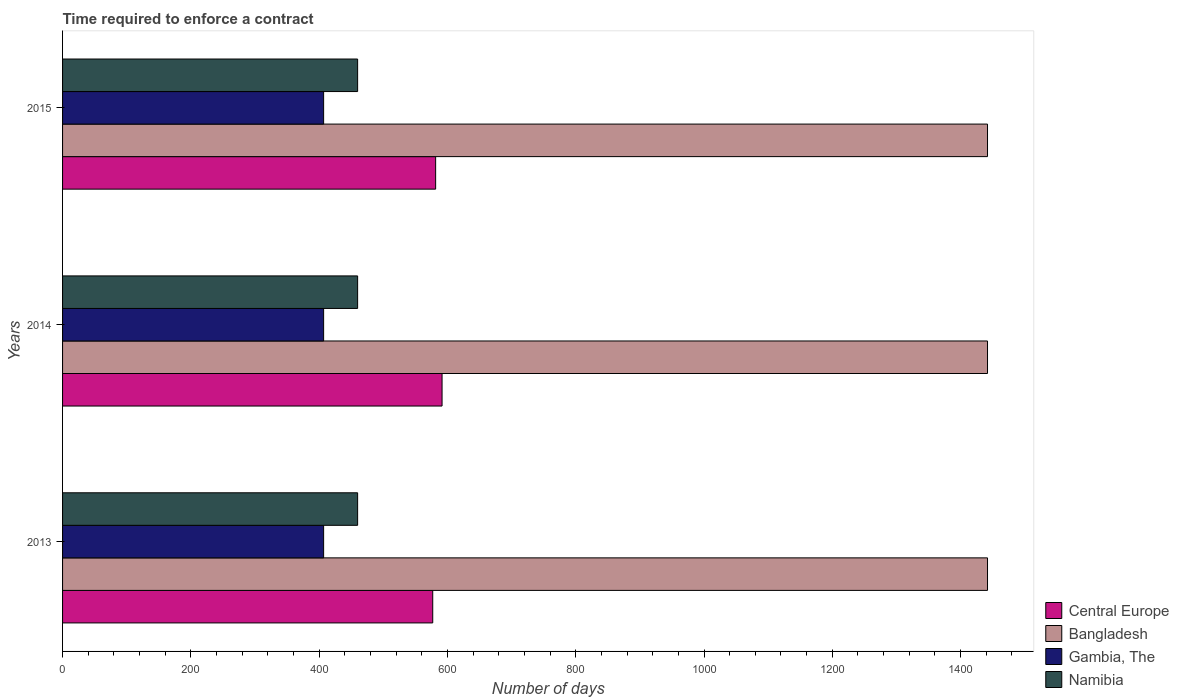How many groups of bars are there?
Keep it short and to the point. 3. Are the number of bars per tick equal to the number of legend labels?
Give a very brief answer. Yes. Are the number of bars on each tick of the Y-axis equal?
Ensure brevity in your answer.  Yes. What is the label of the 2nd group of bars from the top?
Offer a terse response. 2014. In how many cases, is the number of bars for a given year not equal to the number of legend labels?
Your answer should be very brief. 0. What is the number of days required to enforce a contract in Central Europe in 2014?
Keep it short and to the point. 591.64. Across all years, what is the maximum number of days required to enforce a contract in Namibia?
Your response must be concise. 460. Across all years, what is the minimum number of days required to enforce a contract in Bangladesh?
Ensure brevity in your answer.  1442. What is the total number of days required to enforce a contract in Namibia in the graph?
Your answer should be compact. 1380. What is the difference between the number of days required to enforce a contract in Gambia, The in 2014 and the number of days required to enforce a contract in Central Europe in 2013?
Provide a short and direct response. -170.09. What is the average number of days required to enforce a contract in Bangladesh per year?
Your response must be concise. 1442. In the year 2015, what is the difference between the number of days required to enforce a contract in Central Europe and number of days required to enforce a contract in Namibia?
Make the answer very short. 121.64. In how many years, is the number of days required to enforce a contract in Namibia greater than 1080 days?
Keep it short and to the point. 0. What is the ratio of the number of days required to enforce a contract in Gambia, The in 2013 to that in 2015?
Your answer should be compact. 1. Is the number of days required to enforce a contract in Bangladesh in 2013 less than that in 2014?
Offer a very short reply. No. What is the difference between the highest and the lowest number of days required to enforce a contract in Bangladesh?
Provide a succinct answer. 0. Is the sum of the number of days required to enforce a contract in Gambia, The in 2014 and 2015 greater than the maximum number of days required to enforce a contract in Bangladesh across all years?
Provide a short and direct response. No. Is it the case that in every year, the sum of the number of days required to enforce a contract in Bangladesh and number of days required to enforce a contract in Namibia is greater than the sum of number of days required to enforce a contract in Gambia, The and number of days required to enforce a contract in Central Europe?
Make the answer very short. Yes. What does the 1st bar from the top in 2014 represents?
Make the answer very short. Namibia. What does the 1st bar from the bottom in 2013 represents?
Offer a terse response. Central Europe. Are all the bars in the graph horizontal?
Provide a short and direct response. Yes. How many years are there in the graph?
Keep it short and to the point. 3. Does the graph contain any zero values?
Ensure brevity in your answer.  No. What is the title of the graph?
Offer a very short reply. Time required to enforce a contract. Does "Australia" appear as one of the legend labels in the graph?
Give a very brief answer. No. What is the label or title of the X-axis?
Your answer should be compact. Number of days. What is the label or title of the Y-axis?
Provide a short and direct response. Years. What is the Number of days in Central Europe in 2013?
Offer a very short reply. 577.09. What is the Number of days of Bangladesh in 2013?
Ensure brevity in your answer.  1442. What is the Number of days in Gambia, The in 2013?
Offer a terse response. 407. What is the Number of days of Namibia in 2013?
Keep it short and to the point. 460. What is the Number of days in Central Europe in 2014?
Your answer should be compact. 591.64. What is the Number of days in Bangladesh in 2014?
Offer a very short reply. 1442. What is the Number of days in Gambia, The in 2014?
Make the answer very short. 407. What is the Number of days in Namibia in 2014?
Provide a short and direct response. 460. What is the Number of days of Central Europe in 2015?
Your answer should be very brief. 581.64. What is the Number of days in Bangladesh in 2015?
Ensure brevity in your answer.  1442. What is the Number of days in Gambia, The in 2015?
Make the answer very short. 407. What is the Number of days of Namibia in 2015?
Provide a succinct answer. 460. Across all years, what is the maximum Number of days in Central Europe?
Keep it short and to the point. 591.64. Across all years, what is the maximum Number of days of Bangladesh?
Your response must be concise. 1442. Across all years, what is the maximum Number of days in Gambia, The?
Offer a very short reply. 407. Across all years, what is the maximum Number of days in Namibia?
Your answer should be very brief. 460. Across all years, what is the minimum Number of days in Central Europe?
Provide a short and direct response. 577.09. Across all years, what is the minimum Number of days of Bangladesh?
Offer a very short reply. 1442. Across all years, what is the minimum Number of days of Gambia, The?
Make the answer very short. 407. Across all years, what is the minimum Number of days in Namibia?
Your answer should be compact. 460. What is the total Number of days in Central Europe in the graph?
Your answer should be very brief. 1750.36. What is the total Number of days of Bangladesh in the graph?
Your response must be concise. 4326. What is the total Number of days of Gambia, The in the graph?
Provide a succinct answer. 1221. What is the total Number of days in Namibia in the graph?
Your answer should be very brief. 1380. What is the difference between the Number of days of Central Europe in 2013 and that in 2014?
Offer a very short reply. -14.55. What is the difference between the Number of days of Gambia, The in 2013 and that in 2014?
Offer a terse response. 0. What is the difference between the Number of days of Namibia in 2013 and that in 2014?
Provide a short and direct response. 0. What is the difference between the Number of days of Central Europe in 2013 and that in 2015?
Offer a very short reply. -4.55. What is the difference between the Number of days of Bangladesh in 2013 and that in 2015?
Offer a terse response. 0. What is the difference between the Number of days of Gambia, The in 2013 and that in 2015?
Ensure brevity in your answer.  0. What is the difference between the Number of days of Central Europe in 2014 and that in 2015?
Your answer should be very brief. 10. What is the difference between the Number of days of Gambia, The in 2014 and that in 2015?
Provide a succinct answer. 0. What is the difference between the Number of days in Central Europe in 2013 and the Number of days in Bangladesh in 2014?
Provide a short and direct response. -864.91. What is the difference between the Number of days in Central Europe in 2013 and the Number of days in Gambia, The in 2014?
Provide a short and direct response. 170.09. What is the difference between the Number of days of Central Europe in 2013 and the Number of days of Namibia in 2014?
Keep it short and to the point. 117.09. What is the difference between the Number of days in Bangladesh in 2013 and the Number of days in Gambia, The in 2014?
Give a very brief answer. 1035. What is the difference between the Number of days in Bangladesh in 2013 and the Number of days in Namibia in 2014?
Provide a succinct answer. 982. What is the difference between the Number of days in Gambia, The in 2013 and the Number of days in Namibia in 2014?
Offer a terse response. -53. What is the difference between the Number of days in Central Europe in 2013 and the Number of days in Bangladesh in 2015?
Your response must be concise. -864.91. What is the difference between the Number of days in Central Europe in 2013 and the Number of days in Gambia, The in 2015?
Provide a succinct answer. 170.09. What is the difference between the Number of days of Central Europe in 2013 and the Number of days of Namibia in 2015?
Provide a short and direct response. 117.09. What is the difference between the Number of days in Bangladesh in 2013 and the Number of days in Gambia, The in 2015?
Ensure brevity in your answer.  1035. What is the difference between the Number of days of Bangladesh in 2013 and the Number of days of Namibia in 2015?
Give a very brief answer. 982. What is the difference between the Number of days in Gambia, The in 2013 and the Number of days in Namibia in 2015?
Give a very brief answer. -53. What is the difference between the Number of days of Central Europe in 2014 and the Number of days of Bangladesh in 2015?
Offer a terse response. -850.36. What is the difference between the Number of days in Central Europe in 2014 and the Number of days in Gambia, The in 2015?
Provide a short and direct response. 184.64. What is the difference between the Number of days in Central Europe in 2014 and the Number of days in Namibia in 2015?
Provide a succinct answer. 131.64. What is the difference between the Number of days in Bangladesh in 2014 and the Number of days in Gambia, The in 2015?
Ensure brevity in your answer.  1035. What is the difference between the Number of days of Bangladesh in 2014 and the Number of days of Namibia in 2015?
Keep it short and to the point. 982. What is the difference between the Number of days in Gambia, The in 2014 and the Number of days in Namibia in 2015?
Provide a short and direct response. -53. What is the average Number of days in Central Europe per year?
Keep it short and to the point. 583.45. What is the average Number of days of Bangladesh per year?
Make the answer very short. 1442. What is the average Number of days in Gambia, The per year?
Ensure brevity in your answer.  407. What is the average Number of days in Namibia per year?
Ensure brevity in your answer.  460. In the year 2013, what is the difference between the Number of days of Central Europe and Number of days of Bangladesh?
Make the answer very short. -864.91. In the year 2013, what is the difference between the Number of days in Central Europe and Number of days in Gambia, The?
Ensure brevity in your answer.  170.09. In the year 2013, what is the difference between the Number of days of Central Europe and Number of days of Namibia?
Your response must be concise. 117.09. In the year 2013, what is the difference between the Number of days in Bangladesh and Number of days in Gambia, The?
Ensure brevity in your answer.  1035. In the year 2013, what is the difference between the Number of days in Bangladesh and Number of days in Namibia?
Your answer should be very brief. 982. In the year 2013, what is the difference between the Number of days in Gambia, The and Number of days in Namibia?
Ensure brevity in your answer.  -53. In the year 2014, what is the difference between the Number of days in Central Europe and Number of days in Bangladesh?
Offer a very short reply. -850.36. In the year 2014, what is the difference between the Number of days of Central Europe and Number of days of Gambia, The?
Keep it short and to the point. 184.64. In the year 2014, what is the difference between the Number of days of Central Europe and Number of days of Namibia?
Your answer should be compact. 131.64. In the year 2014, what is the difference between the Number of days of Bangladesh and Number of days of Gambia, The?
Offer a terse response. 1035. In the year 2014, what is the difference between the Number of days in Bangladesh and Number of days in Namibia?
Your answer should be compact. 982. In the year 2014, what is the difference between the Number of days in Gambia, The and Number of days in Namibia?
Keep it short and to the point. -53. In the year 2015, what is the difference between the Number of days in Central Europe and Number of days in Bangladesh?
Provide a short and direct response. -860.36. In the year 2015, what is the difference between the Number of days in Central Europe and Number of days in Gambia, The?
Your answer should be compact. 174.64. In the year 2015, what is the difference between the Number of days in Central Europe and Number of days in Namibia?
Keep it short and to the point. 121.64. In the year 2015, what is the difference between the Number of days in Bangladesh and Number of days in Gambia, The?
Offer a very short reply. 1035. In the year 2015, what is the difference between the Number of days of Bangladesh and Number of days of Namibia?
Keep it short and to the point. 982. In the year 2015, what is the difference between the Number of days in Gambia, The and Number of days in Namibia?
Your answer should be very brief. -53. What is the ratio of the Number of days in Central Europe in 2013 to that in 2014?
Give a very brief answer. 0.98. What is the ratio of the Number of days in Bangladesh in 2013 to that in 2014?
Your answer should be very brief. 1. What is the ratio of the Number of days in Gambia, The in 2013 to that in 2014?
Provide a succinct answer. 1. What is the ratio of the Number of days of Namibia in 2013 to that in 2014?
Provide a short and direct response. 1. What is the ratio of the Number of days in Central Europe in 2013 to that in 2015?
Provide a succinct answer. 0.99. What is the ratio of the Number of days of Bangladesh in 2013 to that in 2015?
Offer a terse response. 1. What is the ratio of the Number of days of Namibia in 2013 to that in 2015?
Provide a succinct answer. 1. What is the ratio of the Number of days of Central Europe in 2014 to that in 2015?
Give a very brief answer. 1.02. What is the ratio of the Number of days in Bangladesh in 2014 to that in 2015?
Your response must be concise. 1. What is the ratio of the Number of days of Namibia in 2014 to that in 2015?
Make the answer very short. 1. What is the difference between the highest and the lowest Number of days in Central Europe?
Your answer should be very brief. 14.55. What is the difference between the highest and the lowest Number of days in Gambia, The?
Offer a very short reply. 0. 